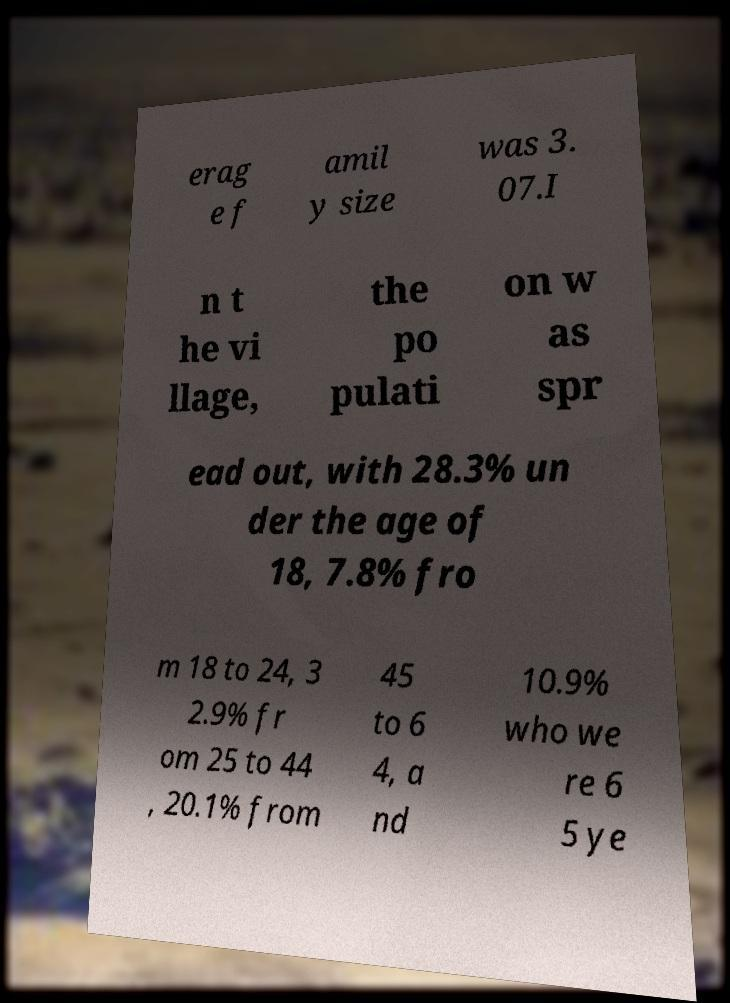There's text embedded in this image that I need extracted. Can you transcribe it verbatim? erag e f amil y size was 3. 07.I n t he vi llage, the po pulati on w as spr ead out, with 28.3% un der the age of 18, 7.8% fro m 18 to 24, 3 2.9% fr om 25 to 44 , 20.1% from 45 to 6 4, a nd 10.9% who we re 6 5 ye 